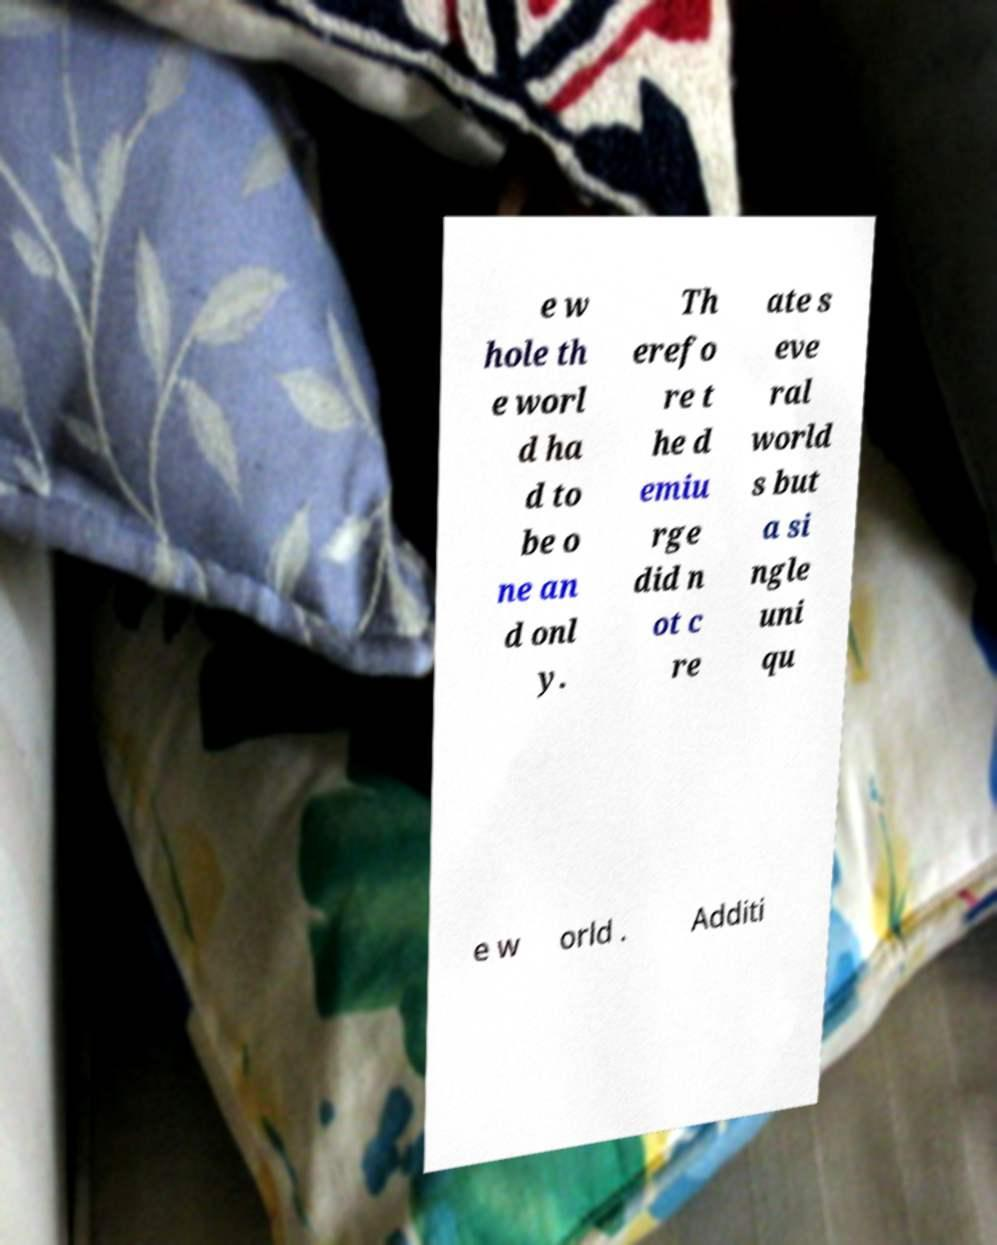Please read and relay the text visible in this image. What does it say? e w hole th e worl d ha d to be o ne an d onl y. Th erefo re t he d emiu rge did n ot c re ate s eve ral world s but a si ngle uni qu e w orld . Additi 